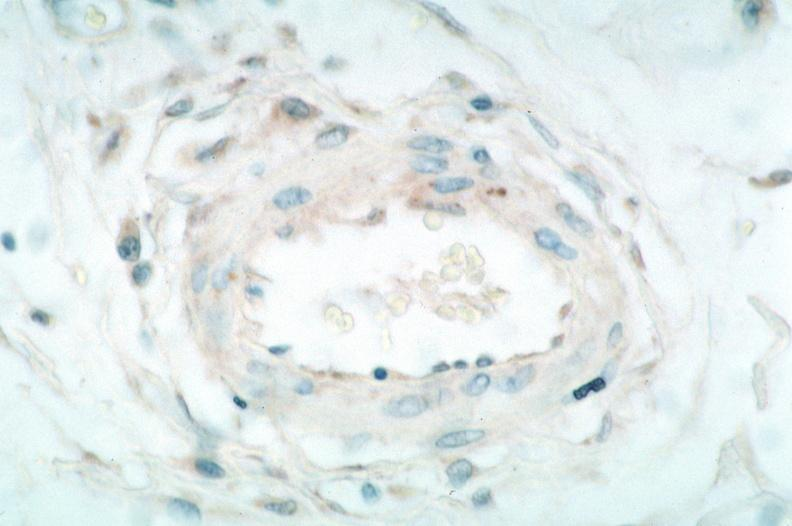what spotted fever, immunoperoxidase staining vessels for rickettsia rickettsii?
Answer the question using a single word or phrase. Rocky mountain 